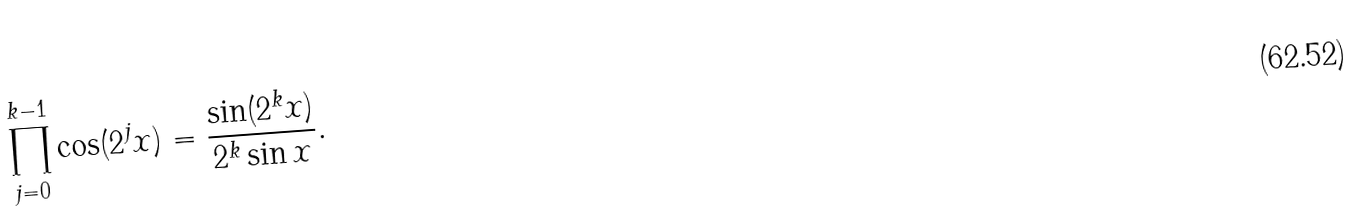Convert formula to latex. <formula><loc_0><loc_0><loc_500><loc_500>\prod _ { j = 0 } ^ { k - 1 } \cos ( 2 ^ { j } x ) = { \frac { \sin ( 2 ^ { k } x ) } { 2 ^ { k } \sin x } } .</formula> 